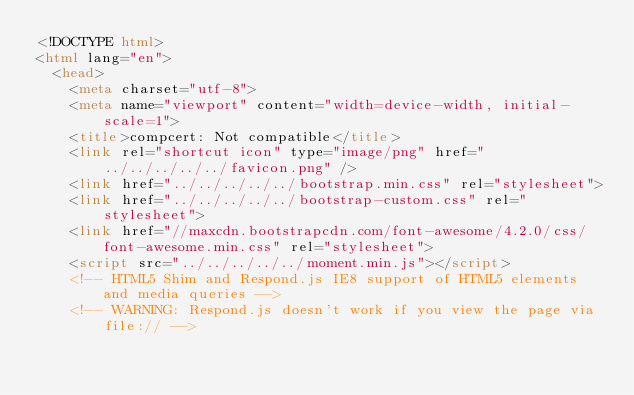Convert code to text. <code><loc_0><loc_0><loc_500><loc_500><_HTML_><!DOCTYPE html>
<html lang="en">
  <head>
    <meta charset="utf-8">
    <meta name="viewport" content="width=device-width, initial-scale=1">
    <title>compcert: Not compatible</title>
    <link rel="shortcut icon" type="image/png" href="../../../../../favicon.png" />
    <link href="../../../../../bootstrap.min.css" rel="stylesheet">
    <link href="../../../../../bootstrap-custom.css" rel="stylesheet">
    <link href="//maxcdn.bootstrapcdn.com/font-awesome/4.2.0/css/font-awesome.min.css" rel="stylesheet">
    <script src="../../../../../moment.min.js"></script>
    <!-- HTML5 Shim and Respond.js IE8 support of HTML5 elements and media queries -->
    <!-- WARNING: Respond.js doesn't work if you view the page via file:// --></code> 